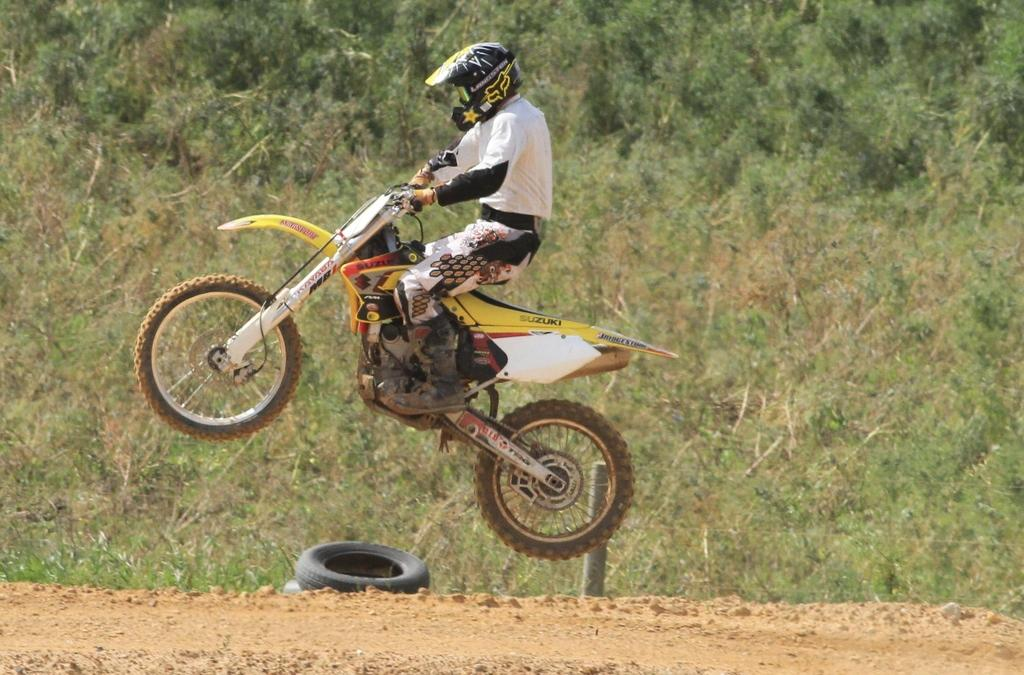What is the main subject of the image? There is a person riding a motorbike in the image. What type of terrain can be seen in the image? There is grass visible in the image. What other natural elements are present in the image? There are trees in the image. Is there any indication of a route or path in the image? Yes, there is a path in the image. What type of plants can be seen growing on the person's flesh in the image? There is no indication of any plants growing on the person's flesh in the image. 